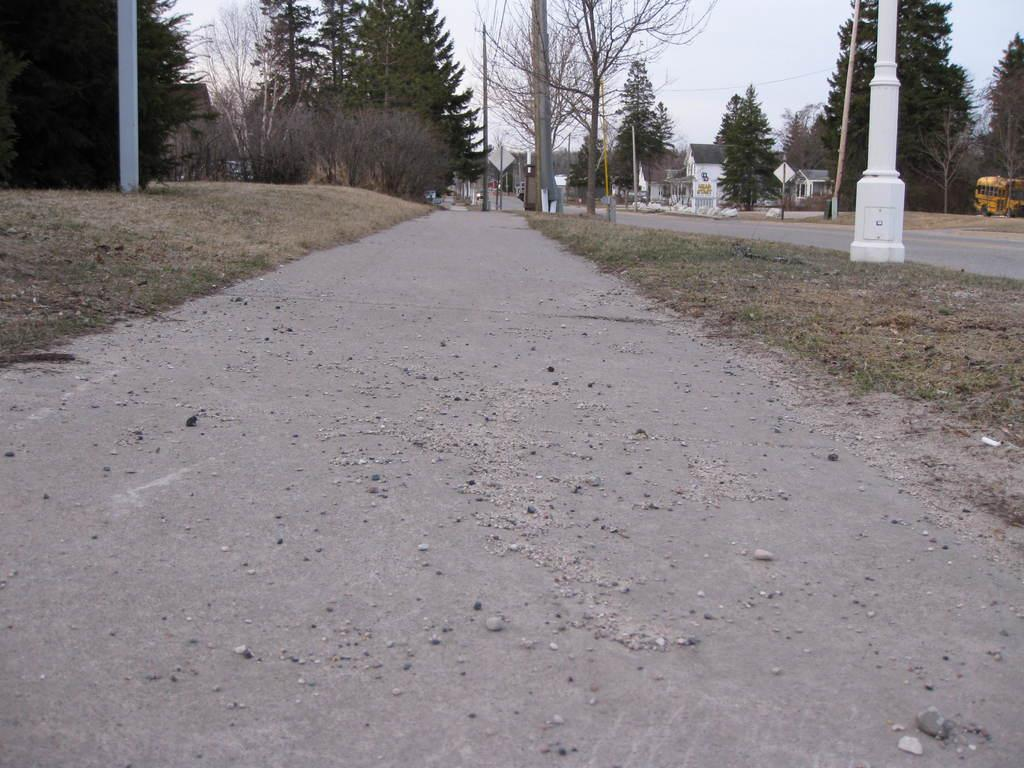What is the main feature of the image? There is a road in the image. What else can be seen alongside the road? Electric poles and cables, as well as buildings, are visible in the image. Are there any vehicles present in the image? Yes, there are two vehicles in the image. What type of vegetation can be seen in the image? Grass is visible in the image. What else is visible in the background? The sky is visible in the image. What song is the goose singing in the image? There is no goose present in the image, so it cannot be singing a song. 